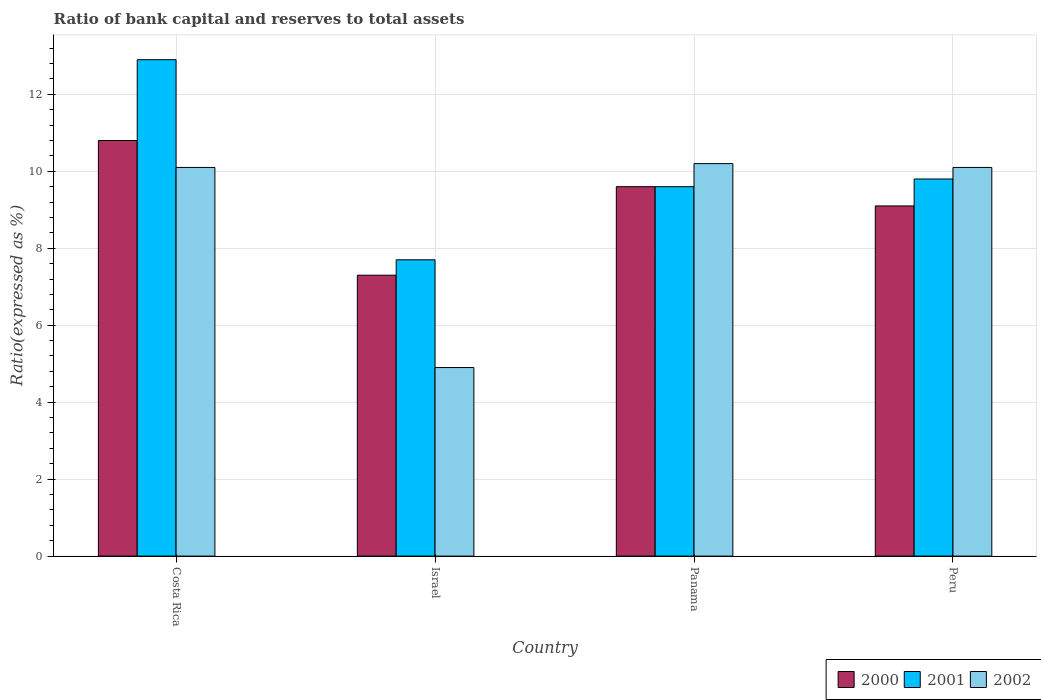How many different coloured bars are there?
Provide a short and direct response. 3. How many groups of bars are there?
Give a very brief answer. 4. Are the number of bars per tick equal to the number of legend labels?
Ensure brevity in your answer.  Yes. How many bars are there on the 3rd tick from the left?
Your answer should be compact. 3. How many bars are there on the 4th tick from the right?
Offer a very short reply. 3. What is the label of the 4th group of bars from the left?
Ensure brevity in your answer.  Peru. What is the ratio of bank capital and reserves to total assets in 2000 in Peru?
Provide a short and direct response. 9.1. In which country was the ratio of bank capital and reserves to total assets in 2001 maximum?
Offer a very short reply. Costa Rica. In which country was the ratio of bank capital and reserves to total assets in 2001 minimum?
Keep it short and to the point. Israel. What is the difference between the ratio of bank capital and reserves to total assets in 2002 in Costa Rica and that in Israel?
Your answer should be very brief. 5.2. What is the difference between the ratio of bank capital and reserves to total assets in 2000 in Costa Rica and the ratio of bank capital and reserves to total assets in 2002 in Panama?
Ensure brevity in your answer.  0.6. What is the average ratio of bank capital and reserves to total assets in 2000 per country?
Ensure brevity in your answer.  9.2. What is the difference between the ratio of bank capital and reserves to total assets of/in 2002 and ratio of bank capital and reserves to total assets of/in 2001 in Panama?
Give a very brief answer. 0.6. What is the ratio of the ratio of bank capital and reserves to total assets in 2000 in Costa Rica to that in Israel?
Your answer should be very brief. 1.48. Is the ratio of bank capital and reserves to total assets in 2002 in Israel less than that in Panama?
Offer a very short reply. Yes. Is the difference between the ratio of bank capital and reserves to total assets in 2002 in Panama and Peru greater than the difference between the ratio of bank capital and reserves to total assets in 2001 in Panama and Peru?
Your answer should be compact. Yes. What is the difference between the highest and the second highest ratio of bank capital and reserves to total assets in 2001?
Provide a succinct answer. -3.1. What is the difference between the highest and the lowest ratio of bank capital and reserves to total assets in 2000?
Provide a short and direct response. 3.5. Is the sum of the ratio of bank capital and reserves to total assets in 2002 in Panama and Peru greater than the maximum ratio of bank capital and reserves to total assets in 2000 across all countries?
Offer a terse response. Yes. How many countries are there in the graph?
Provide a succinct answer. 4. What is the difference between two consecutive major ticks on the Y-axis?
Give a very brief answer. 2. Does the graph contain any zero values?
Provide a succinct answer. No. Where does the legend appear in the graph?
Provide a succinct answer. Bottom right. How are the legend labels stacked?
Ensure brevity in your answer.  Horizontal. What is the title of the graph?
Keep it short and to the point. Ratio of bank capital and reserves to total assets. Does "1973" appear as one of the legend labels in the graph?
Your response must be concise. No. What is the label or title of the X-axis?
Offer a terse response. Country. What is the label or title of the Y-axis?
Offer a terse response. Ratio(expressed as %). What is the Ratio(expressed as %) in 2000 in Costa Rica?
Provide a succinct answer. 10.8. What is the Ratio(expressed as %) of 2001 in Costa Rica?
Your answer should be very brief. 12.9. What is the Ratio(expressed as %) of 2002 in Costa Rica?
Give a very brief answer. 10.1. What is the Ratio(expressed as %) in 2002 in Israel?
Keep it short and to the point. 4.9. What is the Ratio(expressed as %) of 2001 in Panama?
Offer a terse response. 9.6. What is the Ratio(expressed as %) of 2000 in Peru?
Offer a terse response. 9.1. Across all countries, what is the maximum Ratio(expressed as %) in 2000?
Provide a succinct answer. 10.8. Across all countries, what is the maximum Ratio(expressed as %) of 2002?
Provide a short and direct response. 10.2. Across all countries, what is the minimum Ratio(expressed as %) of 2000?
Provide a succinct answer. 7.3. What is the total Ratio(expressed as %) in 2000 in the graph?
Make the answer very short. 36.8. What is the total Ratio(expressed as %) of 2002 in the graph?
Keep it short and to the point. 35.3. What is the difference between the Ratio(expressed as %) in 2000 in Costa Rica and that in Panama?
Make the answer very short. 1.2. What is the difference between the Ratio(expressed as %) in 2002 in Costa Rica and that in Panama?
Give a very brief answer. -0.1. What is the difference between the Ratio(expressed as %) in 2000 in Costa Rica and that in Peru?
Keep it short and to the point. 1.7. What is the difference between the Ratio(expressed as %) of 2001 in Costa Rica and that in Peru?
Your response must be concise. 3.1. What is the difference between the Ratio(expressed as %) in 2002 in Costa Rica and that in Peru?
Give a very brief answer. 0. What is the difference between the Ratio(expressed as %) of 2000 in Israel and that in Panama?
Give a very brief answer. -2.3. What is the difference between the Ratio(expressed as %) of 2001 in Israel and that in Panama?
Ensure brevity in your answer.  -1.9. What is the difference between the Ratio(expressed as %) in 2000 in Israel and that in Peru?
Your answer should be compact. -1.8. What is the difference between the Ratio(expressed as %) in 2002 in Israel and that in Peru?
Ensure brevity in your answer.  -5.2. What is the difference between the Ratio(expressed as %) of 2002 in Panama and that in Peru?
Offer a terse response. 0.1. What is the difference between the Ratio(expressed as %) in 2001 in Costa Rica and the Ratio(expressed as %) in 2002 in Israel?
Provide a short and direct response. 8. What is the difference between the Ratio(expressed as %) of 2000 in Costa Rica and the Ratio(expressed as %) of 2002 in Panama?
Make the answer very short. 0.6. What is the difference between the Ratio(expressed as %) in 2000 in Costa Rica and the Ratio(expressed as %) in 2001 in Peru?
Provide a short and direct response. 1. What is the difference between the Ratio(expressed as %) of 2001 in Costa Rica and the Ratio(expressed as %) of 2002 in Peru?
Your response must be concise. 2.8. What is the difference between the Ratio(expressed as %) in 2000 in Israel and the Ratio(expressed as %) in 2002 in Panama?
Your answer should be very brief. -2.9. What is the difference between the Ratio(expressed as %) in 2000 in Israel and the Ratio(expressed as %) in 2001 in Peru?
Your answer should be very brief. -2.5. What is the average Ratio(expressed as %) of 2001 per country?
Give a very brief answer. 10. What is the average Ratio(expressed as %) in 2002 per country?
Offer a very short reply. 8.82. What is the difference between the Ratio(expressed as %) in 2000 and Ratio(expressed as %) in 2001 in Costa Rica?
Provide a short and direct response. -2.1. What is the difference between the Ratio(expressed as %) in 2000 and Ratio(expressed as %) in 2002 in Costa Rica?
Your response must be concise. 0.7. What is the difference between the Ratio(expressed as %) in 2001 and Ratio(expressed as %) in 2002 in Costa Rica?
Offer a very short reply. 2.8. What is the difference between the Ratio(expressed as %) in 2001 and Ratio(expressed as %) in 2002 in Israel?
Offer a very short reply. 2.8. What is the difference between the Ratio(expressed as %) in 2000 and Ratio(expressed as %) in 2001 in Panama?
Offer a terse response. 0. What is the difference between the Ratio(expressed as %) of 2000 and Ratio(expressed as %) of 2002 in Panama?
Make the answer very short. -0.6. What is the difference between the Ratio(expressed as %) of 2001 and Ratio(expressed as %) of 2002 in Panama?
Make the answer very short. -0.6. What is the difference between the Ratio(expressed as %) in 2000 and Ratio(expressed as %) in 2002 in Peru?
Keep it short and to the point. -1. What is the ratio of the Ratio(expressed as %) of 2000 in Costa Rica to that in Israel?
Keep it short and to the point. 1.48. What is the ratio of the Ratio(expressed as %) of 2001 in Costa Rica to that in Israel?
Provide a short and direct response. 1.68. What is the ratio of the Ratio(expressed as %) of 2002 in Costa Rica to that in Israel?
Provide a short and direct response. 2.06. What is the ratio of the Ratio(expressed as %) of 2001 in Costa Rica to that in Panama?
Offer a terse response. 1.34. What is the ratio of the Ratio(expressed as %) in 2002 in Costa Rica to that in Panama?
Ensure brevity in your answer.  0.99. What is the ratio of the Ratio(expressed as %) in 2000 in Costa Rica to that in Peru?
Your answer should be very brief. 1.19. What is the ratio of the Ratio(expressed as %) of 2001 in Costa Rica to that in Peru?
Provide a succinct answer. 1.32. What is the ratio of the Ratio(expressed as %) of 2002 in Costa Rica to that in Peru?
Ensure brevity in your answer.  1. What is the ratio of the Ratio(expressed as %) of 2000 in Israel to that in Panama?
Your answer should be compact. 0.76. What is the ratio of the Ratio(expressed as %) in 2001 in Israel to that in Panama?
Your answer should be very brief. 0.8. What is the ratio of the Ratio(expressed as %) of 2002 in Israel to that in Panama?
Your response must be concise. 0.48. What is the ratio of the Ratio(expressed as %) of 2000 in Israel to that in Peru?
Provide a short and direct response. 0.8. What is the ratio of the Ratio(expressed as %) of 2001 in Israel to that in Peru?
Make the answer very short. 0.79. What is the ratio of the Ratio(expressed as %) of 2002 in Israel to that in Peru?
Your response must be concise. 0.49. What is the ratio of the Ratio(expressed as %) in 2000 in Panama to that in Peru?
Your response must be concise. 1.05. What is the ratio of the Ratio(expressed as %) in 2001 in Panama to that in Peru?
Give a very brief answer. 0.98. What is the ratio of the Ratio(expressed as %) of 2002 in Panama to that in Peru?
Your answer should be very brief. 1.01. What is the difference between the highest and the second highest Ratio(expressed as %) in 2000?
Your response must be concise. 1.2. What is the difference between the highest and the second highest Ratio(expressed as %) in 2002?
Your answer should be very brief. 0.1. 